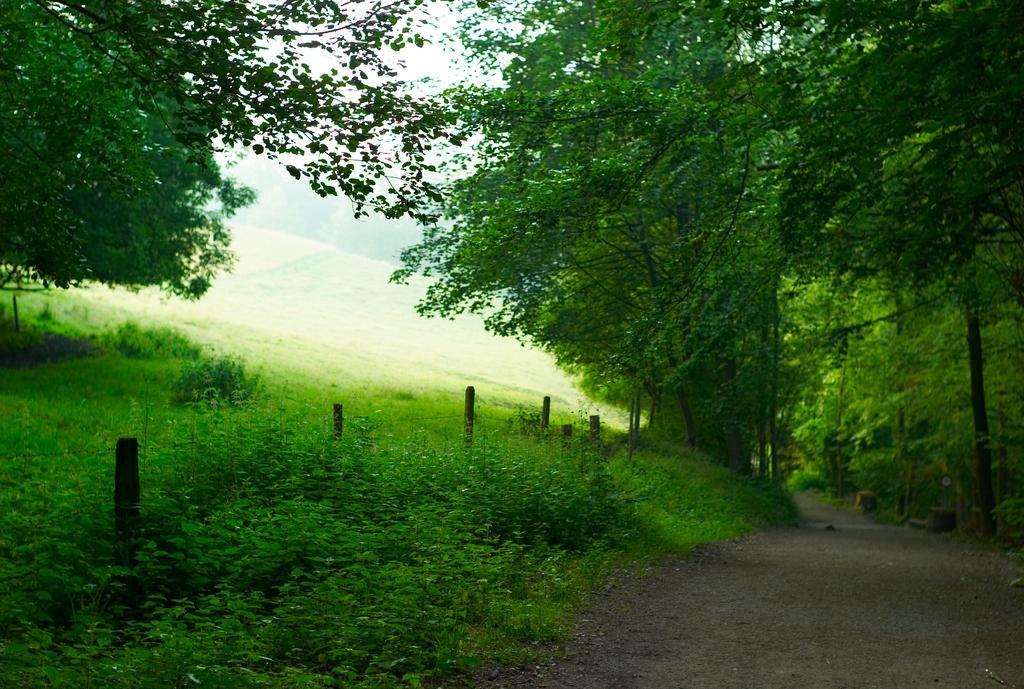Can you describe this image briefly? In this image there are plants towards the bottom of the image, there is the sky towards the top of the image, there are trees, there is road towards the bottom of the image. 